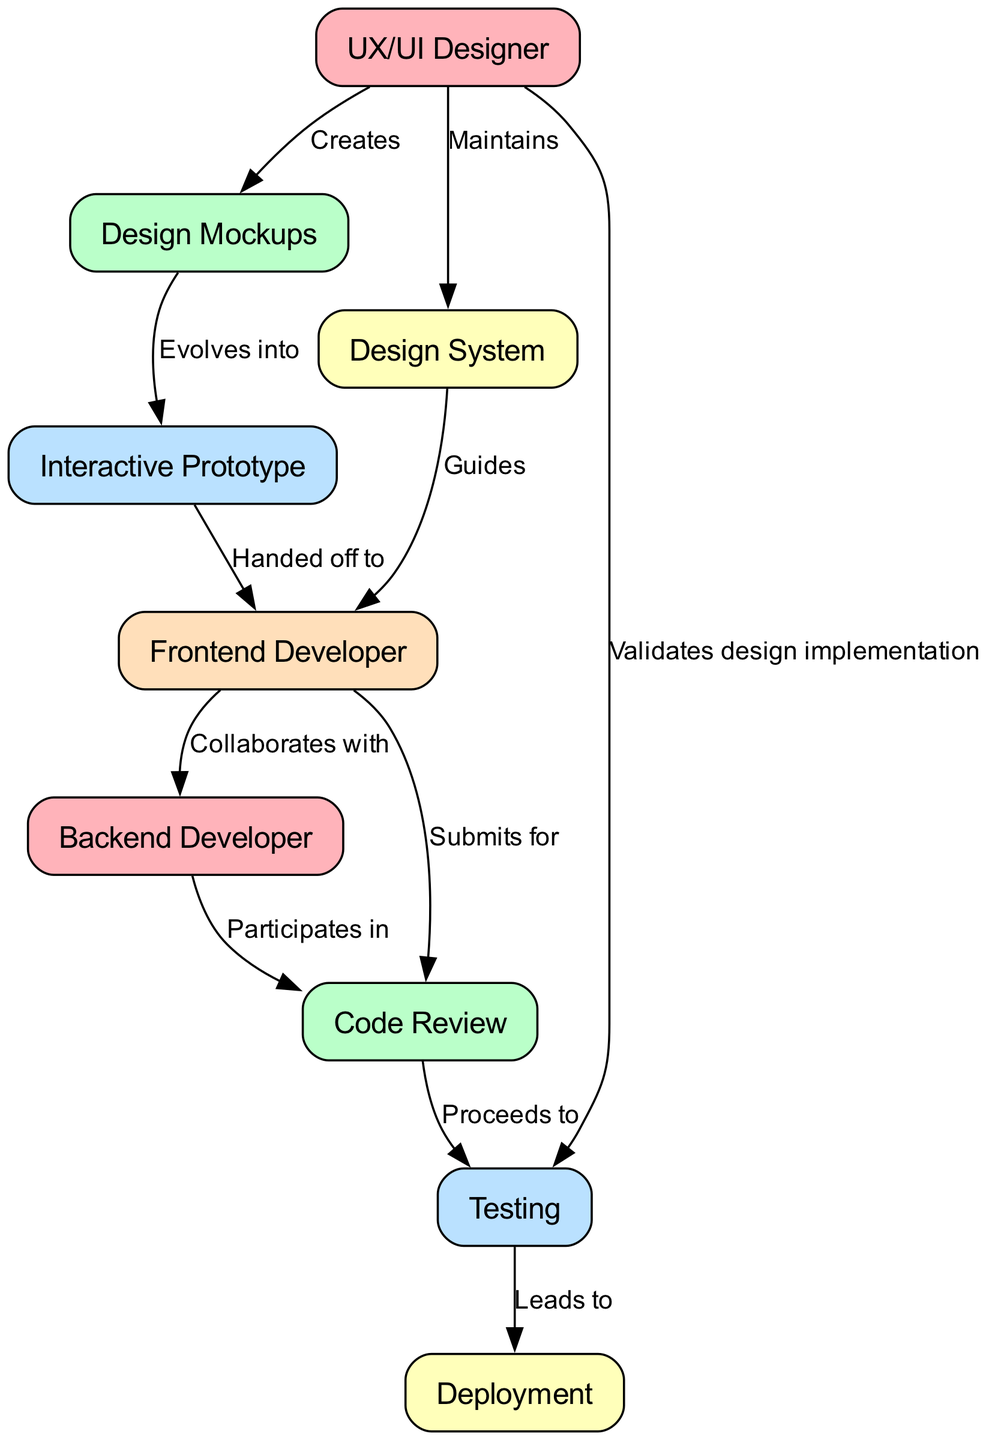What is the starting point of the process? The starting point is the "UX/UI Designer," which is the first node in the diagram, indicating where the process begins.
Answer: UX/UI Designer How many nodes are present in the diagram? By counting each distinct role or component in the diagram, we find there are a total of nine nodes listed.
Answer: 9 What is the relationship between "Design Mockups" and "Interactive Prototype"? The diagram specifies that "Design Mockups" evolves into "Interactive Prototype," indicating a progression in the design process.
Answer: Evolves into Which node receives the handoff from the "Interactive Prototype"? The flow of the diagram shows that the "Frontend Developer" is the next node receiving the handoff from the "Interactive Prototype."
Answer: Frontend Developer What validation step is performed by the UX/UI Designer? According to the diagram, the "UX/UI Designer" validates design implementation in the "Testing" phase, ensuring that the designs are correctly deployed.
Answer: Validates design implementation Which nodes are directly linked to the "Code Review" node? The diagram reveals that both the "Frontend Developer" and "Backend Developer" are connected to the "Code Review" node, indicating their involvement in this phase.
Answer: Frontend Developer, Backend Developer What comes after "Testing" in the process? The diagram indicates that "Testing" leads to "Deployment," which is the next step in the process.
Answer: Deployment How many edges connect the "Frontend Developer" to other nodes? By reviewing the diagram, we observe that the "Frontend Developer" is connected to three edges leading to "Backend Developer," "Code Review," and also receiving guidance from "Design System."
Answer: 3 What is the role of the "Design System" in the process? The diagram indicates that the "Design System" guides the "Frontend Developer," serving as a reference for design standards and components during development.
Answer: Guides 